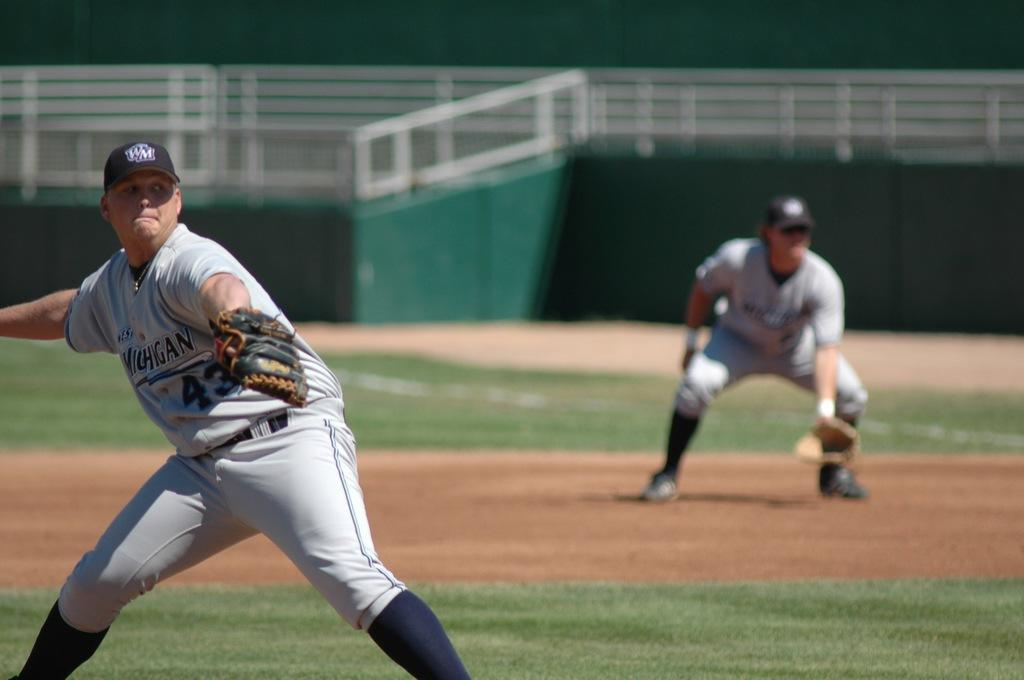How many people are present in the image? There are two players in the image. What is the position of the players in the image? The players are on the ground. What can be seen in the background of the image? There is a fence in the background of the image. What type of popcorn is being used as a prop in the image? There is no popcorn present in the image. What type of leaf can be seen falling from the tree in the image? There is no tree or leaf present in the image. 